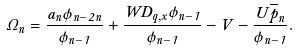<formula> <loc_0><loc_0><loc_500><loc_500>\Omega _ { n } = \frac { a _ { n } \phi _ { n - 2 } \Theta _ { n } } { \phi _ { n - 1 } } + \frac { W D _ { q , x } \phi _ { n - 1 } } { \phi _ { n - 1 } } - V - \frac { U \overline { p } _ { n } } { \phi _ { n - 1 } } .</formula> 